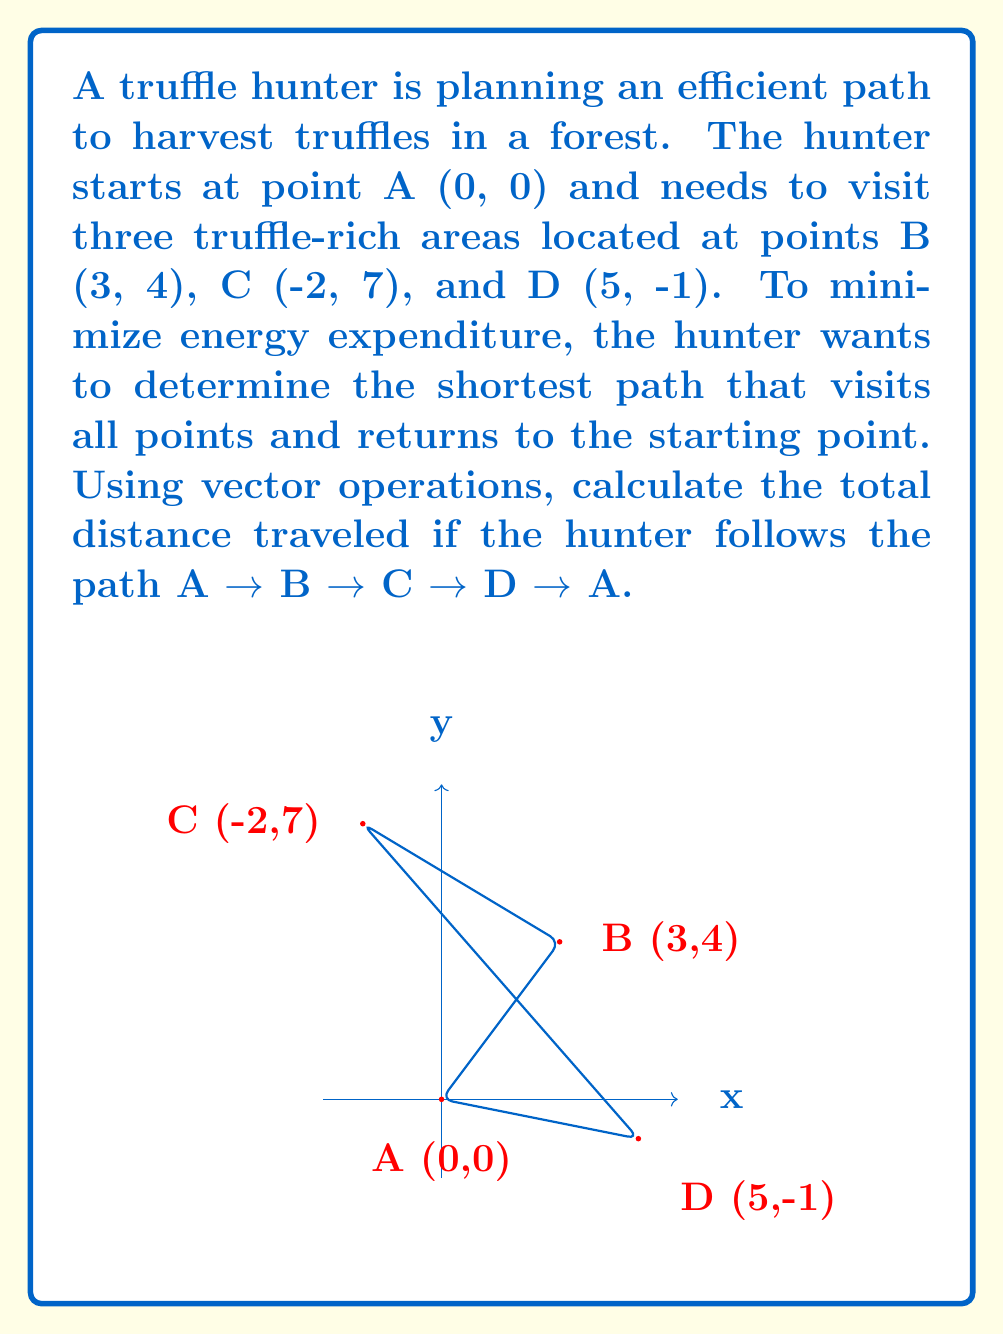Provide a solution to this math problem. To solve this problem, we'll use vector operations to calculate the distance between each pair of points and then sum these distances.

Step 1: Calculate the vectors for each segment of the path.
$\vec{AB} = B - A = (3-0, 4-0) = (3, 4)$
$\vec{BC} = C - B = (-2-3, 7-4) = (-5, 3)$
$\vec{CD} = D - C = (5-(-2), -1-7) = (7, -8)$
$\vec{DA} = A - D = (0-5, 0-(-1)) = (-5, 1)$

Step 2: Calculate the magnitude (length) of each vector using the Pythagorean theorem.
$|\vec{AB}| = \sqrt{3^2 + 4^2} = \sqrt{9 + 16} = \sqrt{25} = 5$
$|\vec{BC}| = \sqrt{(-5)^2 + 3^2} = \sqrt{25 + 9} = \sqrt{34}$
$|\vec{CD}| = \sqrt{7^2 + (-8)^2} = \sqrt{49 + 64} = \sqrt{113}$
$|\vec{DA}| = \sqrt{(-5)^2 + 1^2} = \sqrt{25 + 1} = \sqrt{26}$

Step 3: Sum the magnitudes to get the total distance traveled.
Total distance = $|\vec{AB}| + |\vec{BC}| + |\vec{CD}| + |\vec{DA}|$
$= 5 + \sqrt{34} + \sqrt{113} + \sqrt{26}$

Step 4: Simplify the expression (if needed).
The expression $5 + \sqrt{34} + \sqrt{113} + \sqrt{26}$ cannot be simplified further without approximation.
Answer: $5 + \sqrt{34} + \sqrt{113} + \sqrt{26}$ 